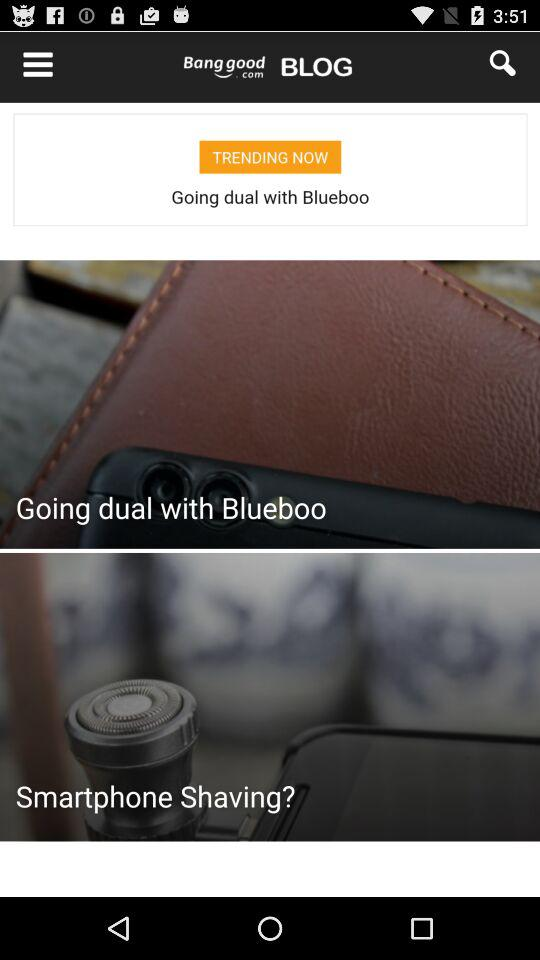How many items are in the shopping cart?
Answer the question using a single word or phrase. 1 